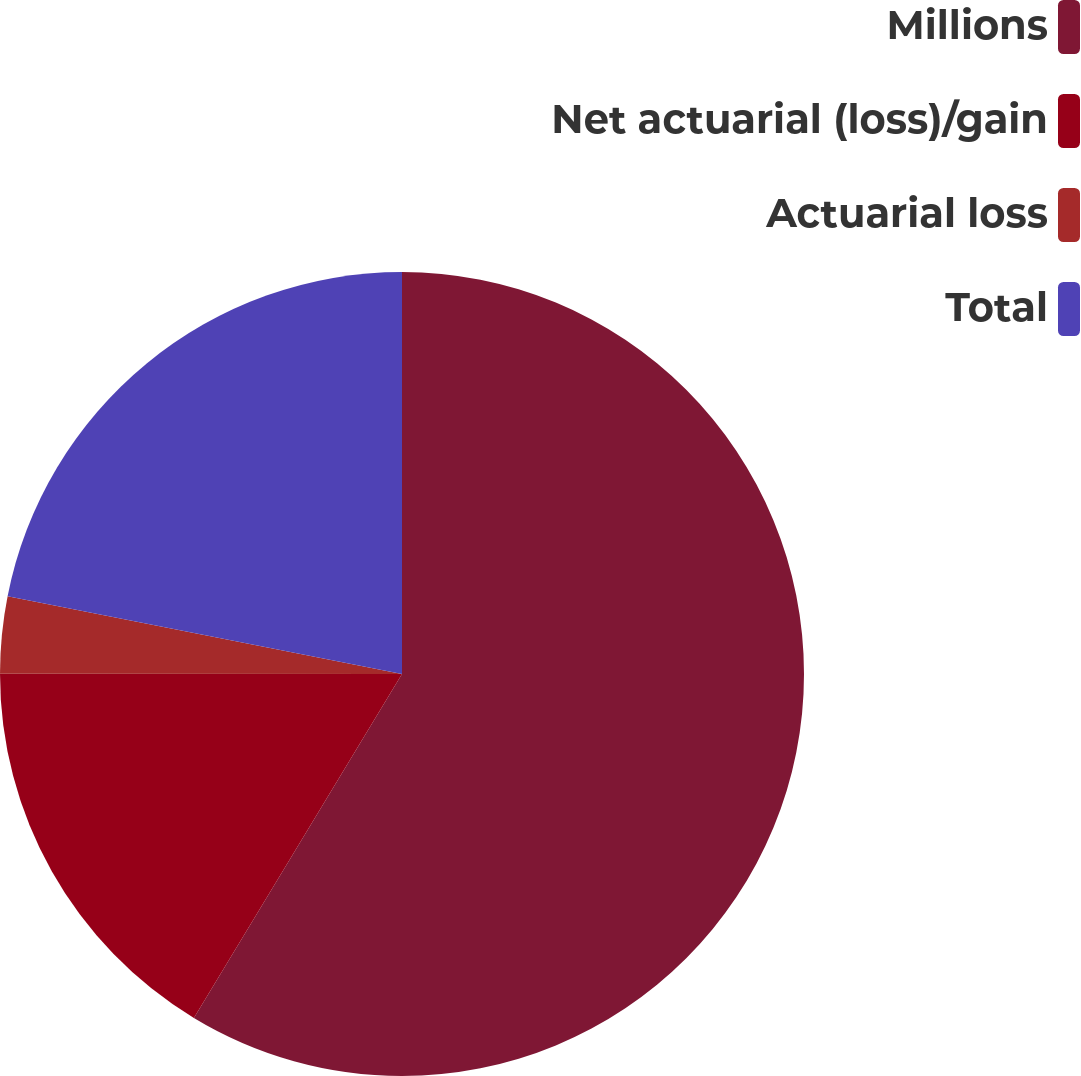Convert chart. <chart><loc_0><loc_0><loc_500><loc_500><pie_chart><fcel>Millions<fcel>Net actuarial (loss)/gain<fcel>Actuarial loss<fcel>Total<nl><fcel>58.66%<fcel>16.35%<fcel>3.09%<fcel>21.9%<nl></chart> 